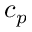<formula> <loc_0><loc_0><loc_500><loc_500>c _ { p }</formula> 